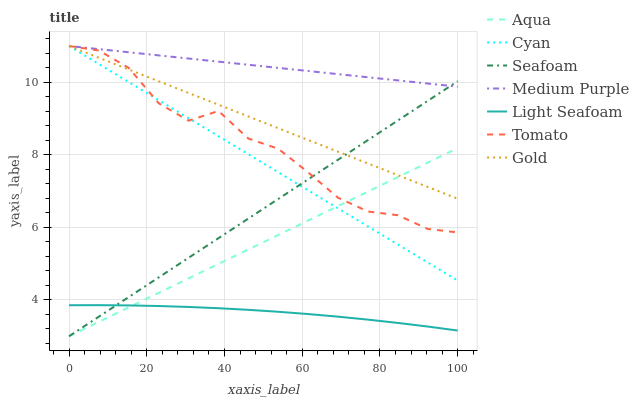Does Light Seafoam have the minimum area under the curve?
Answer yes or no. Yes. Does Medium Purple have the maximum area under the curve?
Answer yes or no. Yes. Does Gold have the minimum area under the curve?
Answer yes or no. No. Does Gold have the maximum area under the curve?
Answer yes or no. No. Is Seafoam the smoothest?
Answer yes or no. Yes. Is Tomato the roughest?
Answer yes or no. Yes. Is Gold the smoothest?
Answer yes or no. No. Is Gold the roughest?
Answer yes or no. No. Does Aqua have the lowest value?
Answer yes or no. Yes. Does Gold have the lowest value?
Answer yes or no. No. Does Cyan have the highest value?
Answer yes or no. Yes. Does Aqua have the highest value?
Answer yes or no. No. Is Light Seafoam less than Cyan?
Answer yes or no. Yes. Is Tomato greater than Light Seafoam?
Answer yes or no. Yes. Does Gold intersect Tomato?
Answer yes or no. Yes. Is Gold less than Tomato?
Answer yes or no. No. Is Gold greater than Tomato?
Answer yes or no. No. Does Light Seafoam intersect Cyan?
Answer yes or no. No. 